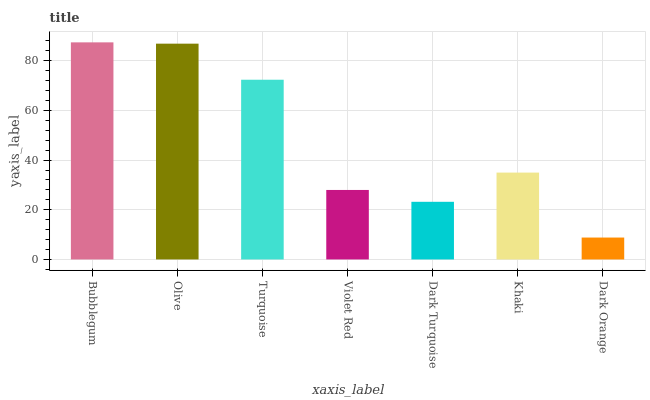Is Dark Orange the minimum?
Answer yes or no. Yes. Is Bubblegum the maximum?
Answer yes or no. Yes. Is Olive the minimum?
Answer yes or no. No. Is Olive the maximum?
Answer yes or no. No. Is Bubblegum greater than Olive?
Answer yes or no. Yes. Is Olive less than Bubblegum?
Answer yes or no. Yes. Is Olive greater than Bubblegum?
Answer yes or no. No. Is Bubblegum less than Olive?
Answer yes or no. No. Is Khaki the high median?
Answer yes or no. Yes. Is Khaki the low median?
Answer yes or no. Yes. Is Olive the high median?
Answer yes or no. No. Is Dark Turquoise the low median?
Answer yes or no. No. 